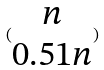Convert formula to latex. <formula><loc_0><loc_0><loc_500><loc_500>( \begin{matrix} n \\ 0 . 5 1 n \end{matrix} )</formula> 